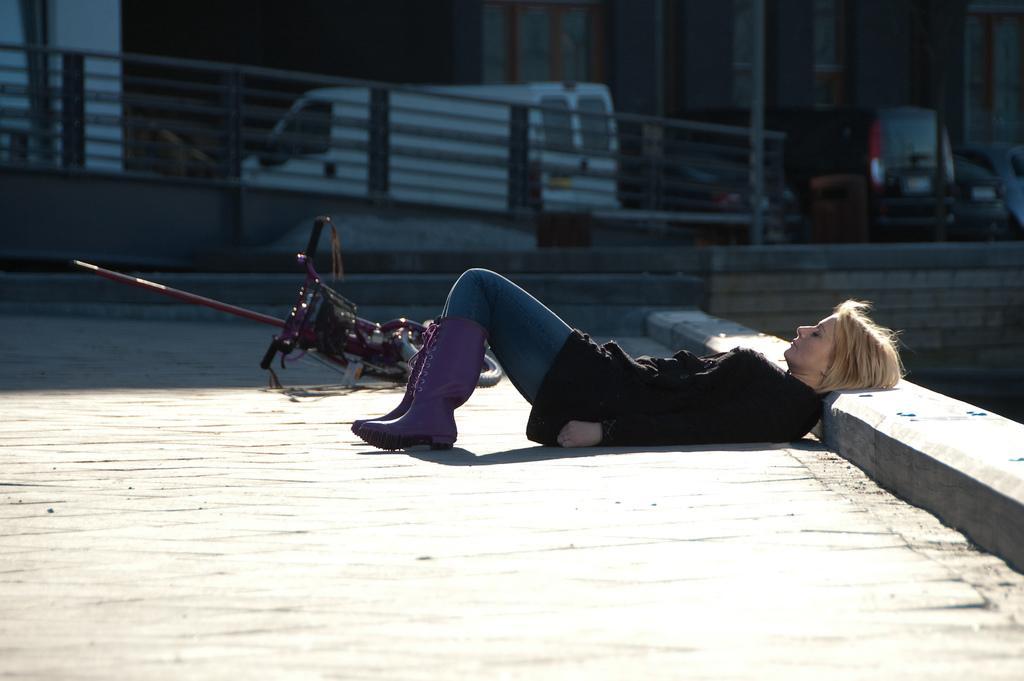Describe this image in one or two sentences. This is the woman laying on the ground. I can see a bicycle. I think these are the vehicles. I think these are the iron grilles. 